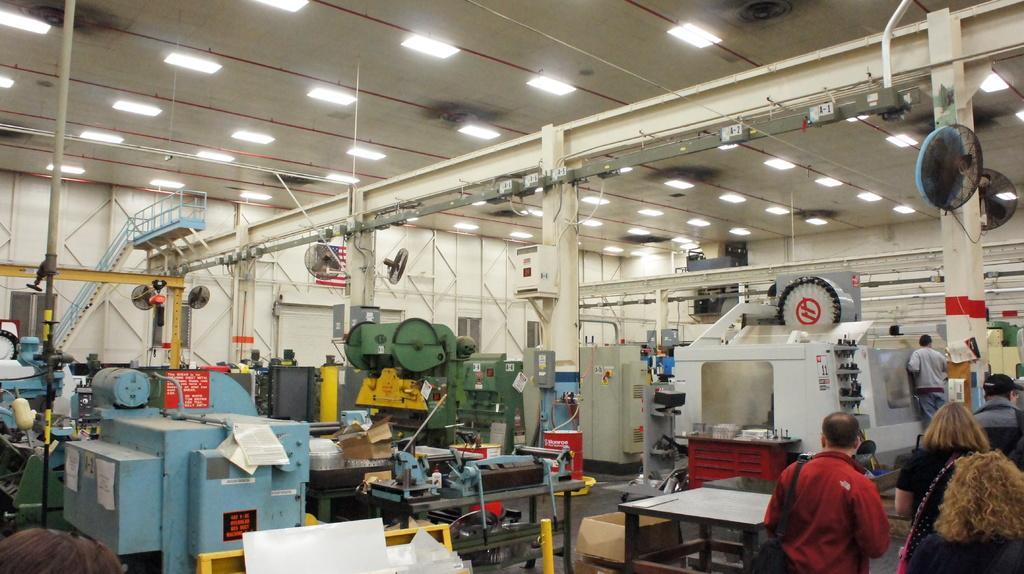Can you describe this image briefly? As we can see in the image there is a white color wall, fans, stairs and few electrical equipment and some people here and there. 